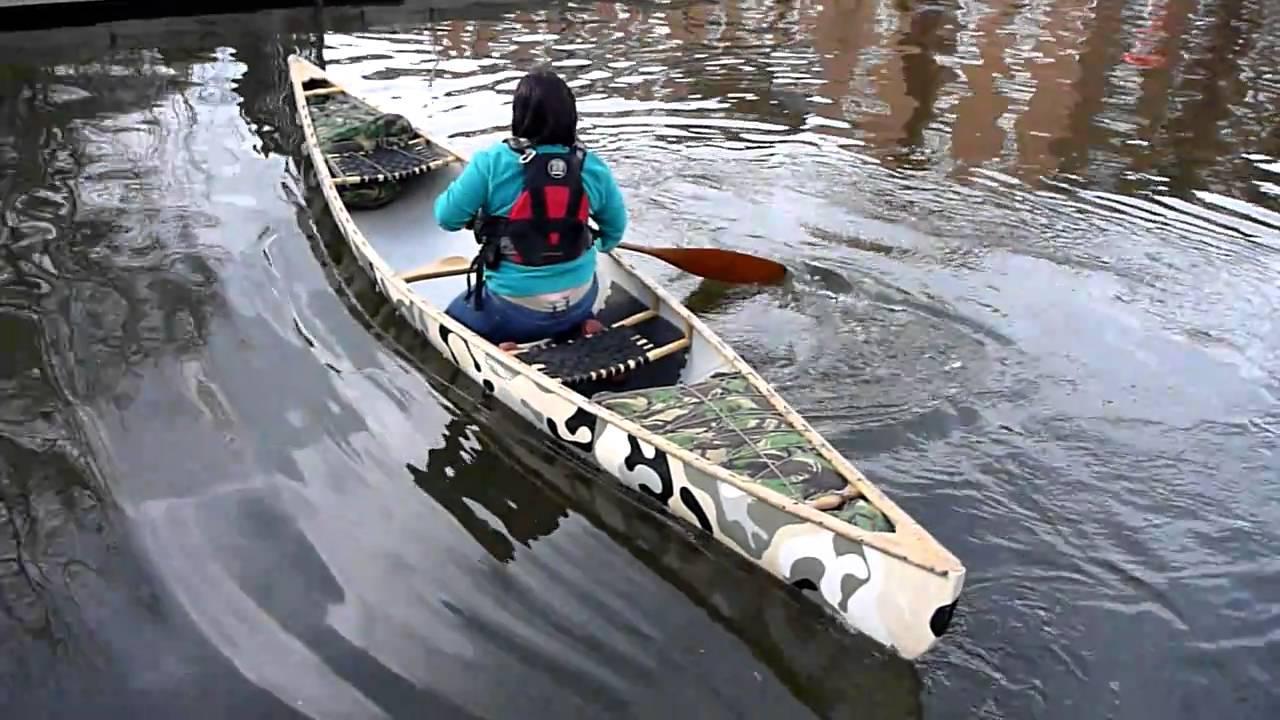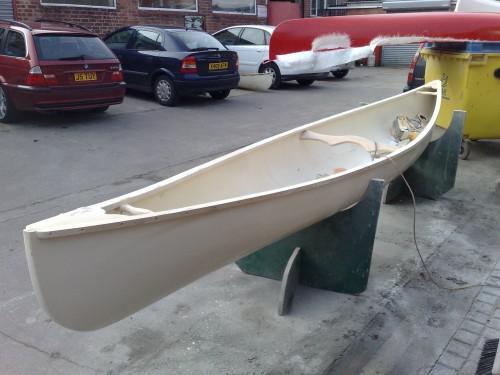The first image is the image on the left, the second image is the image on the right. Evaluate the accuracy of this statement regarding the images: "Two canoes are sitting in the grass next to a building.". Is it true? Answer yes or no. No. The first image is the image on the left, the second image is the image on the right. For the images displayed, is the sentence "Each image features an empty canoe sitting on green grass, and one image features a white canoe next to a strip of dark pavement, with a crumpled blue tarp behind it." factually correct? Answer yes or no. No. 